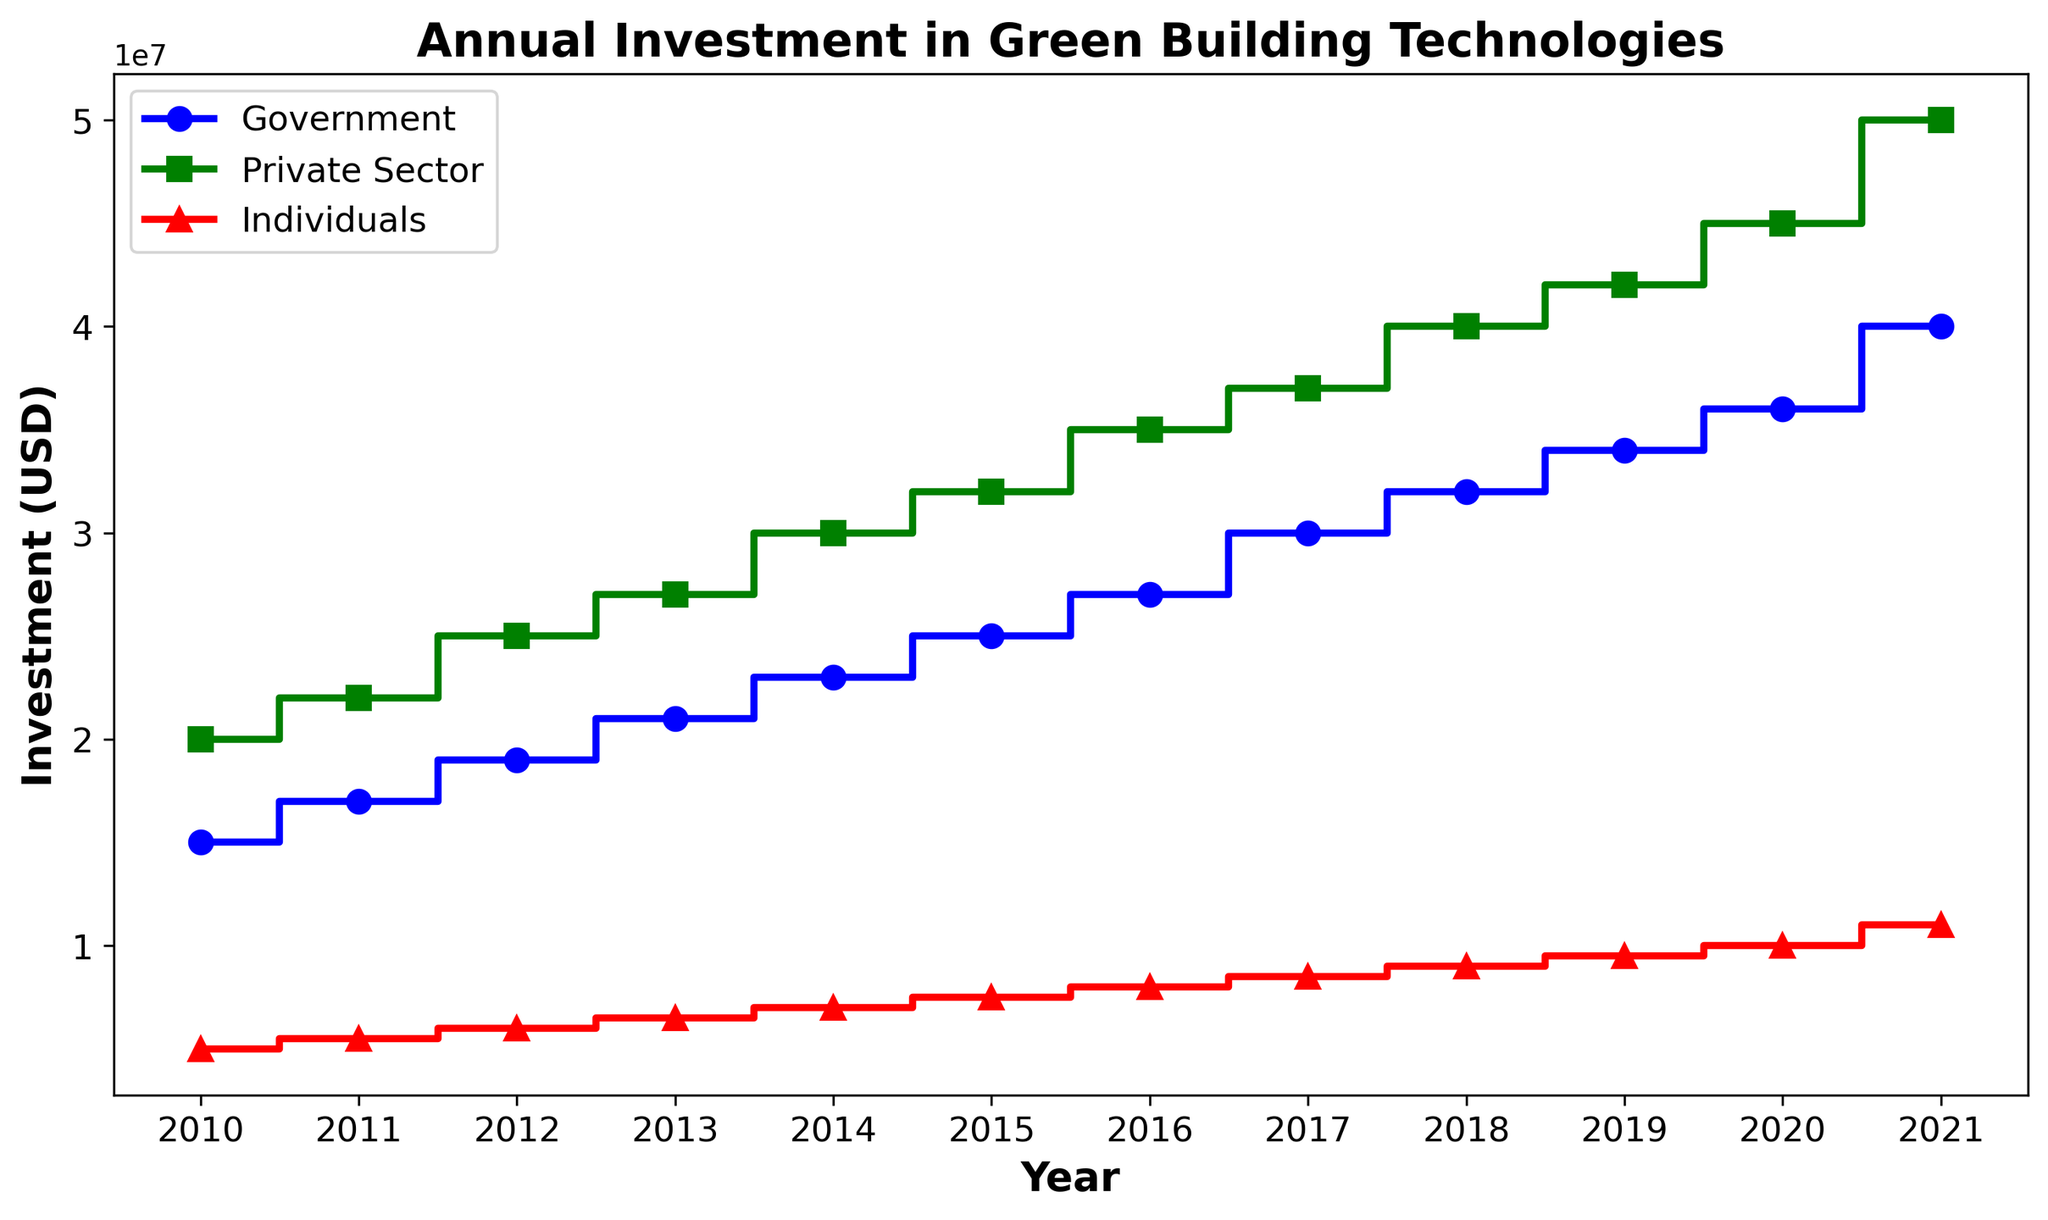What is the total investment in green building technologies from all sources in 2015? To find the total investment in 2015, sum the investments from the Government, Private Sector, and Individuals. The values are $25,000,000 (Government) + $32,000,000 (Private Sector) + $7,500,000 (Individuals) = $64,500,000.
Answer: $64,500,000 Which year had the highest investment from individuals? Review the data points for individual investments each year. The highest investment from individuals is $11,000,000, which occurred in 2021.
Answer: 2021 In which year did the private sector's investment first exceed $40,000,000? Identify the year when the private sector's investment first went beyond $40,000,000. According to the plot, this occurred in 2018.
Answer: 2018 How much more did the government invest in 2021 compared to 2010? Find the investment from the government in 2021 and 2010, then calculate the difference. The values are $40,000,000 (2021) - $15,000,000 (2010) = $25,000,000.
Answer: $25,000,000 What is the average annual investment from the private sector over the given period? Compute the average by summing the private sector investments from 2010 to 2021 and then dividing by the number of years. The total investment is $20,000,000 + $22,000,000 + $25,000,000 + $27,000,000 + $30,000,000 + $32,000,000 + $35,000,000 + $37,000,000 + $40,000,000 + $42,000,000 + $45,000,000 + $50,000,000 = $405,000,000, and the average is $405,000,000 / 12 = $33,750,000.
Answer: $33,750,000 Which sector showed the most significant increase in investment from 2010 to 2021? Calculate the increase for each sector by subtracting the 2010 values from the 2021 values: Government: $40,000,000 - $15,000,000 = $25,000,000, Private Sector: $50,000,000 - $20,000,000 = $30,000,000, Individuals: $11,000,000 - $5,000,000 = $6,000,000. The private sector showed the most significant increase of $30,000,000.
Answer: Private Sector What is the combined investment from the private sector and individuals in 2017? Sum the investments from the private sector and individuals in 2017. The values are $37,000,000 (Private Sector) + $8,500,000 (Individuals) = $45,500,000.
Answer: $45,500,000 By how much did the individual investments increase on average per year from 2010 to 2021? Find the total increase in individual investments from 2010 to 2021 and then divide by the number of years. The increase is $11,000,000 (2021) - $5,000,000 (2010) = $6,000,000. The average increase per year is $6,000,000 / 11 = $545,454.55.
Answer: $545,454.55 